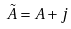Convert formula to latex. <formula><loc_0><loc_0><loc_500><loc_500>\tilde { A } = A + j</formula> 